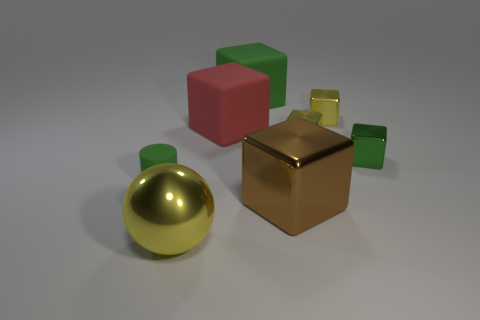What shape is the big shiny object that is to the right of the green rubber object that is right of the tiny cylinder?
Give a very brief answer. Cube. Are the green cylinder and the big thing that is behind the big red rubber block made of the same material?
Offer a terse response. Yes. What number of green shiny objects are the same size as the green rubber cylinder?
Make the answer very short. 1. Is the number of shiny cubes that are to the left of the tiny cylinder less than the number of blue metallic cylinders?
Your response must be concise. No. How many large brown cubes are in front of the big brown metallic thing?
Your response must be concise. 0. What size is the green thing that is right of the big block in front of the small object that is to the left of the big brown object?
Offer a terse response. Small. Is the shape of the large red object the same as the green thing behind the large red cube?
Offer a terse response. Yes. There is a brown thing that is made of the same material as the large yellow ball; what size is it?
Your response must be concise. Large. Is there any other thing that is the same color as the large shiny cube?
Your response must be concise. No. What material is the green block that is on the right side of the big brown object that is right of the yellow metallic thing left of the big brown thing?
Offer a terse response. Metal. 